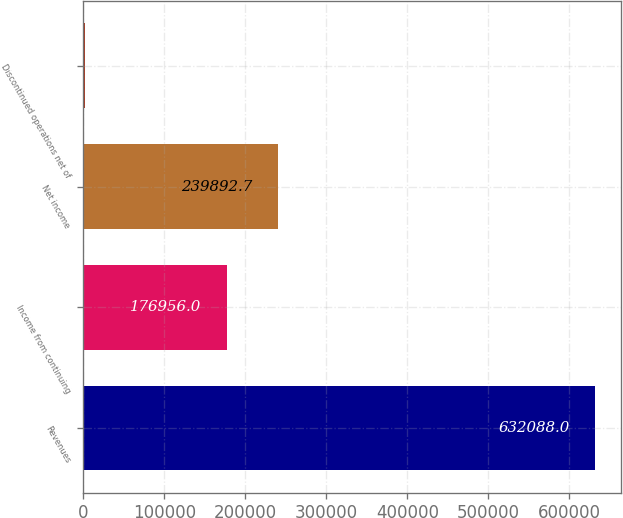Convert chart. <chart><loc_0><loc_0><loc_500><loc_500><bar_chart><fcel>Revenues<fcel>Income from continuing<fcel>Net income<fcel>Discontinued operations net of<nl><fcel>632088<fcel>176956<fcel>239893<fcel>2721<nl></chart> 